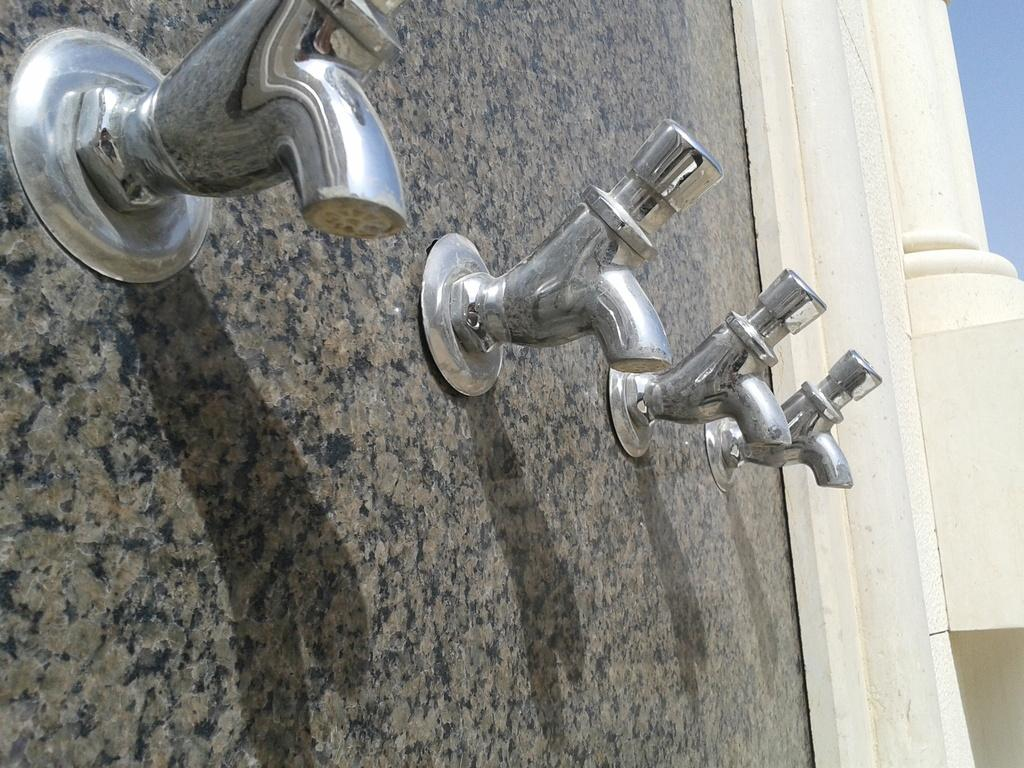What is the main feature in the center of the image? There is a wall in the center of the image. What can be found on the wall? There are taps on the wall. What type of invention is being used for writing on the wall in the image? There is no invention for writing on the wall in the image; the image only shows a wall with taps. 